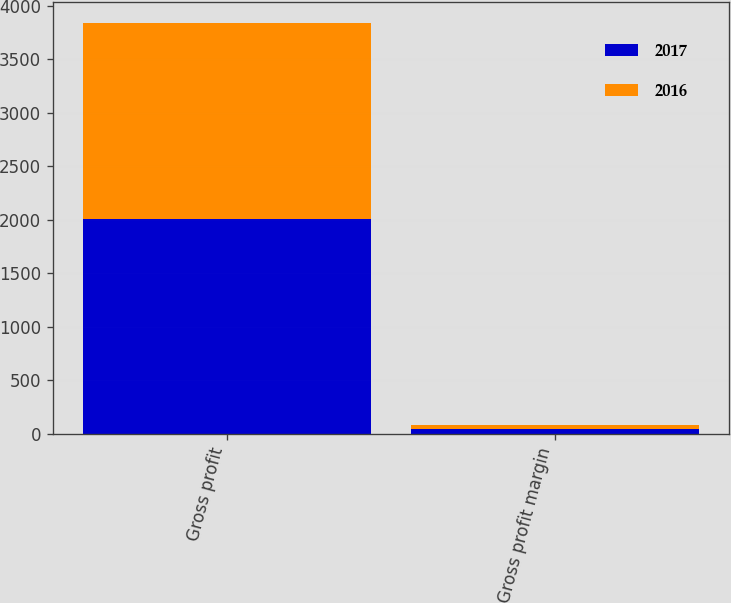Convert chart to OTSL. <chart><loc_0><loc_0><loc_500><loc_500><stacked_bar_chart><ecel><fcel>Gross profit<fcel>Gross profit margin<nl><fcel>2017<fcel>2010.2<fcel>41.6<nl><fcel>2016<fcel>1831.7<fcel>41.5<nl></chart> 